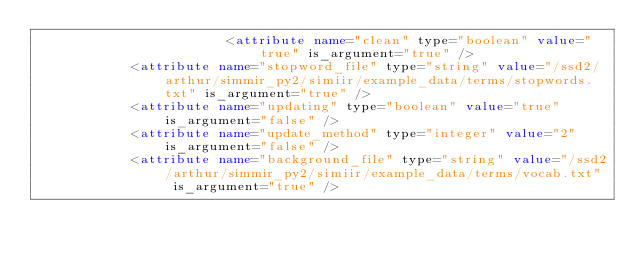Convert code to text. <code><loc_0><loc_0><loc_500><loc_500><_XML_>                        <attribute name="clean" type="boolean" value="true" is_argument="true" />
            <attribute name="stopword_file" type="string" value="/ssd2/arthur/simmir_py2/simiir/example_data/terms/stopwords.txt" is_argument="true" />
            <attribute name="updating" type="boolean" value="true" is_argument="false" />
            <attribute name="update_method" type="integer" value="2" is_argument="false" />
            <attribute name="background_file" type="string" value="/ssd2/arthur/simmir_py2/simiir/example_data/terms/vocab.txt" is_argument="true" /></code> 